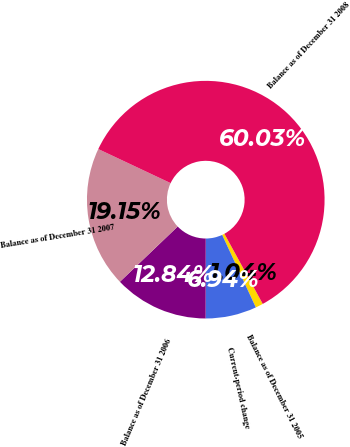<chart> <loc_0><loc_0><loc_500><loc_500><pie_chart><fcel>Balance as of December 31 2005<fcel>Current-period change<fcel>Balance as of December 31 2006<fcel>Balance as of December 31 2007<fcel>Balance as of December 31 2008<nl><fcel>1.04%<fcel>6.94%<fcel>12.84%<fcel>19.15%<fcel>60.04%<nl></chart> 